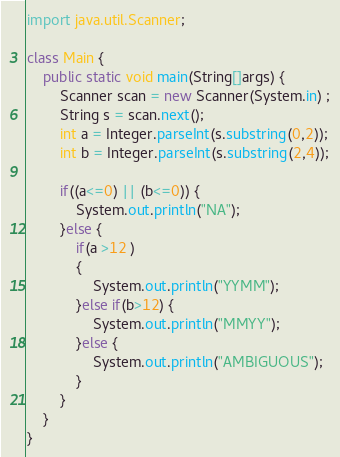<code> <loc_0><loc_0><loc_500><loc_500><_Java_>
import java.util.Scanner;

class Main {
	public static void main(String[]args) {
		Scanner scan = new Scanner(System.in) ;
		String s = scan.next();
		int a = Integer.parseInt(s.substring(0,2));
		int b = Integer.parseInt(s.substring(2,4));
		
		if((a<=0) || (b<=0)) {
			System.out.println("NA");
		}else {
			if(a >12 )
			{
				System.out.println("YYMM");
			}else if(b>12) {
				System.out.println("MMYY");
			}else {
				System.out.println("AMBIGUOUS");
			}
		}
	}
}</code> 